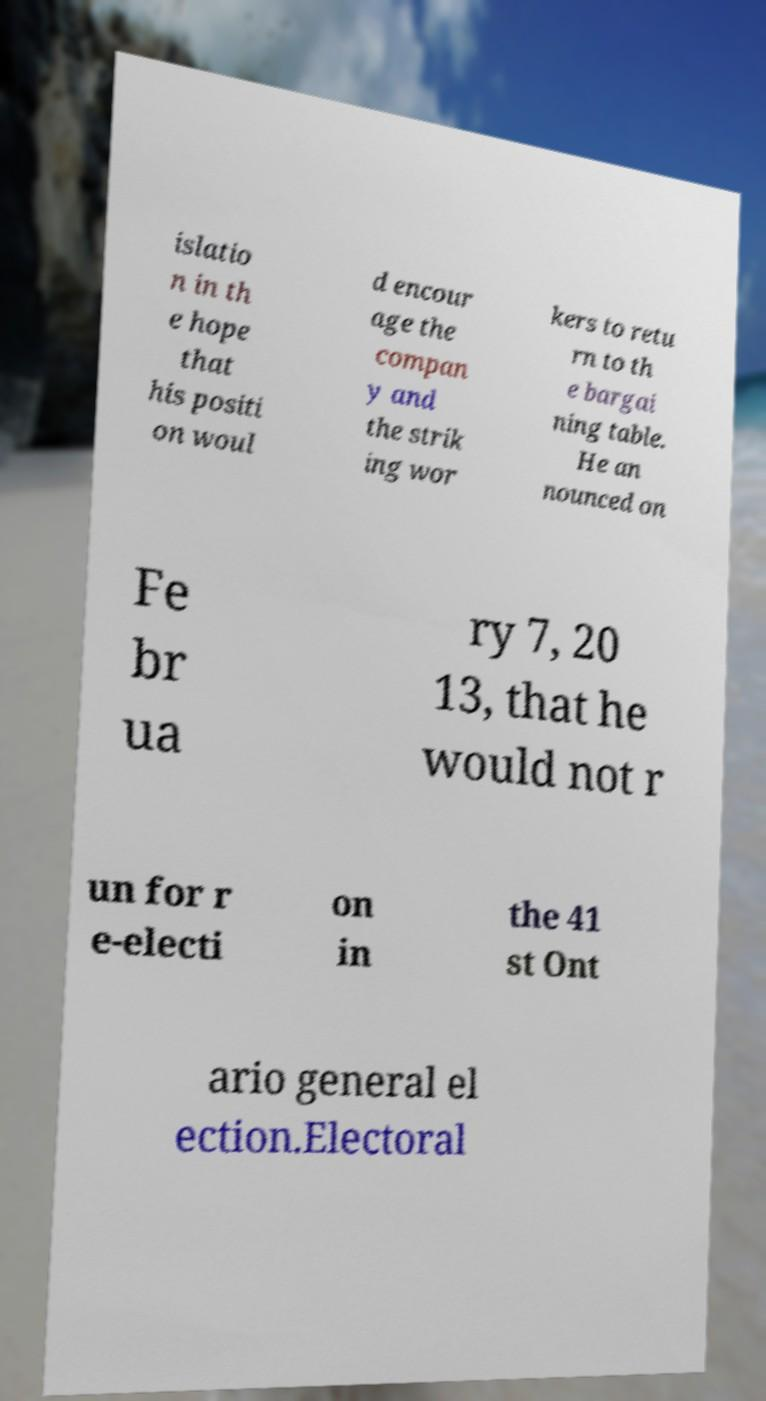Can you read and provide the text displayed in the image?This photo seems to have some interesting text. Can you extract and type it out for me? islatio n in th e hope that his positi on woul d encour age the compan y and the strik ing wor kers to retu rn to th e bargai ning table. He an nounced on Fe br ua ry 7, 20 13, that he would not r un for r e-electi on in the 41 st Ont ario general el ection.Electoral 